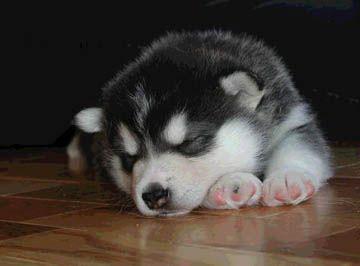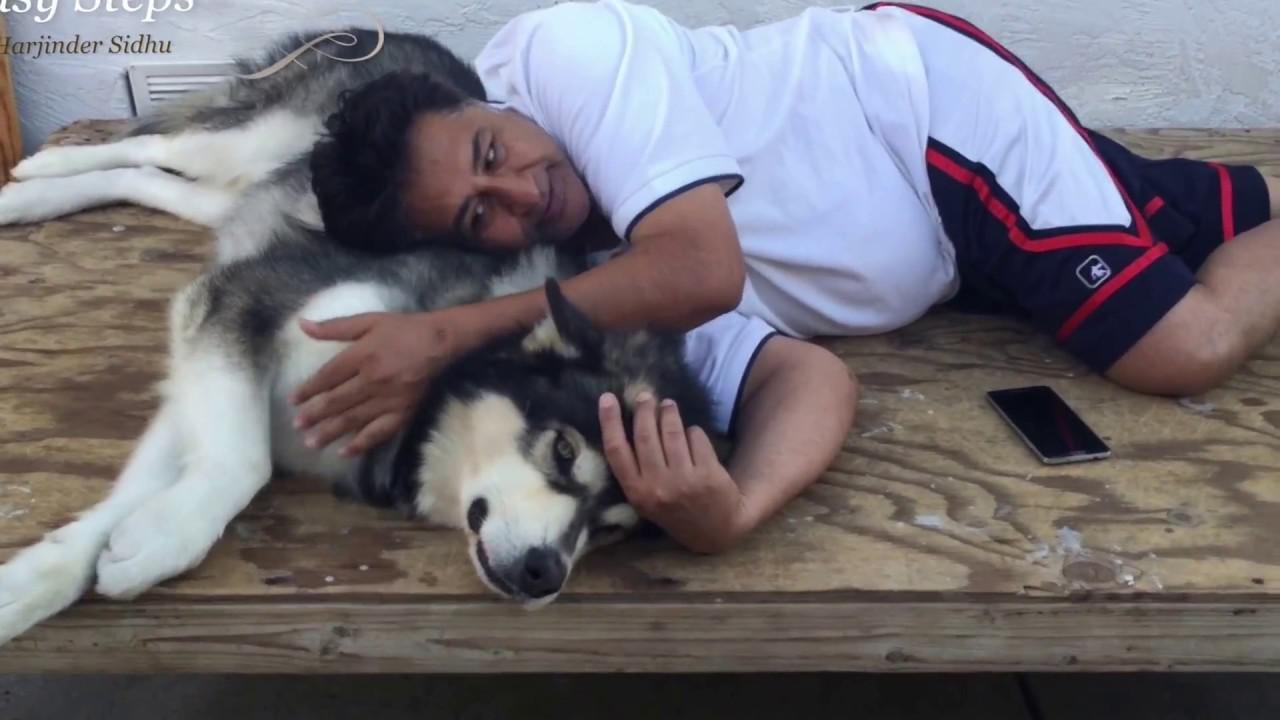The first image is the image on the left, the second image is the image on the right. For the images displayed, is the sentence "There is exactly one dog that is sleeping in each image." factually correct? Answer yes or no. No. 